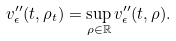<formula> <loc_0><loc_0><loc_500><loc_500>v _ { \epsilon } ^ { \prime \prime } ( t , \rho _ { t } ) = \sup _ { \rho \in \mathbb { R } } v _ { \epsilon } ^ { \prime \prime } ( t , \rho ) .</formula> 